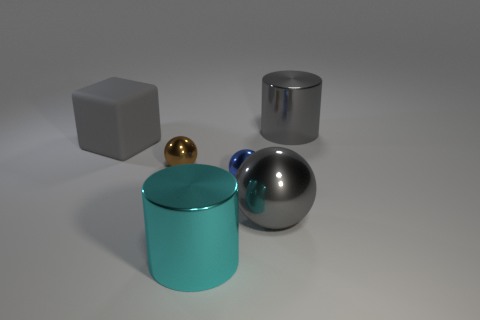Can you tell about the textures of the surfaces of the objects? Certainly, the surfaces of the objects in the image exhibit a variety of textures: the cyan and gray items have smooth and shiny surfaces with a reflective quality, the gold ball has a polished, but less reflective surface, and the gray cube shows a matte finish with minimal reflection, indicating a possibly rougher texture. 